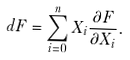Convert formula to latex. <formula><loc_0><loc_0><loc_500><loc_500>d F = \sum _ { i = 0 } ^ { n } X _ { i } \frac { \partial F } { \partial X _ { i } } .</formula> 